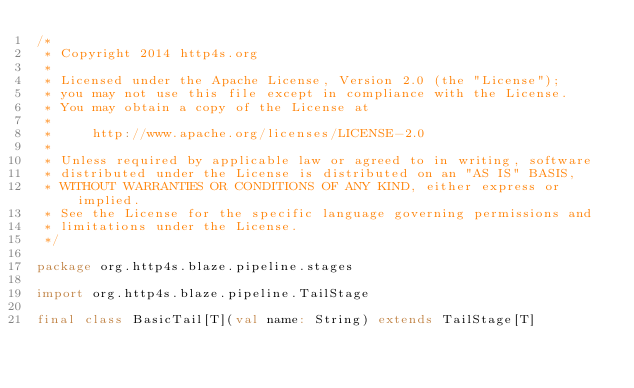<code> <loc_0><loc_0><loc_500><loc_500><_Scala_>/*
 * Copyright 2014 http4s.org
 *
 * Licensed under the Apache License, Version 2.0 (the "License");
 * you may not use this file except in compliance with the License.
 * You may obtain a copy of the License at
 *
 *     http://www.apache.org/licenses/LICENSE-2.0
 *
 * Unless required by applicable law or agreed to in writing, software
 * distributed under the License is distributed on an "AS IS" BASIS,
 * WITHOUT WARRANTIES OR CONDITIONS OF ANY KIND, either express or implied.
 * See the License for the specific language governing permissions and
 * limitations under the License.
 */

package org.http4s.blaze.pipeline.stages

import org.http4s.blaze.pipeline.TailStage

final class BasicTail[T](val name: String) extends TailStage[T]
</code> 